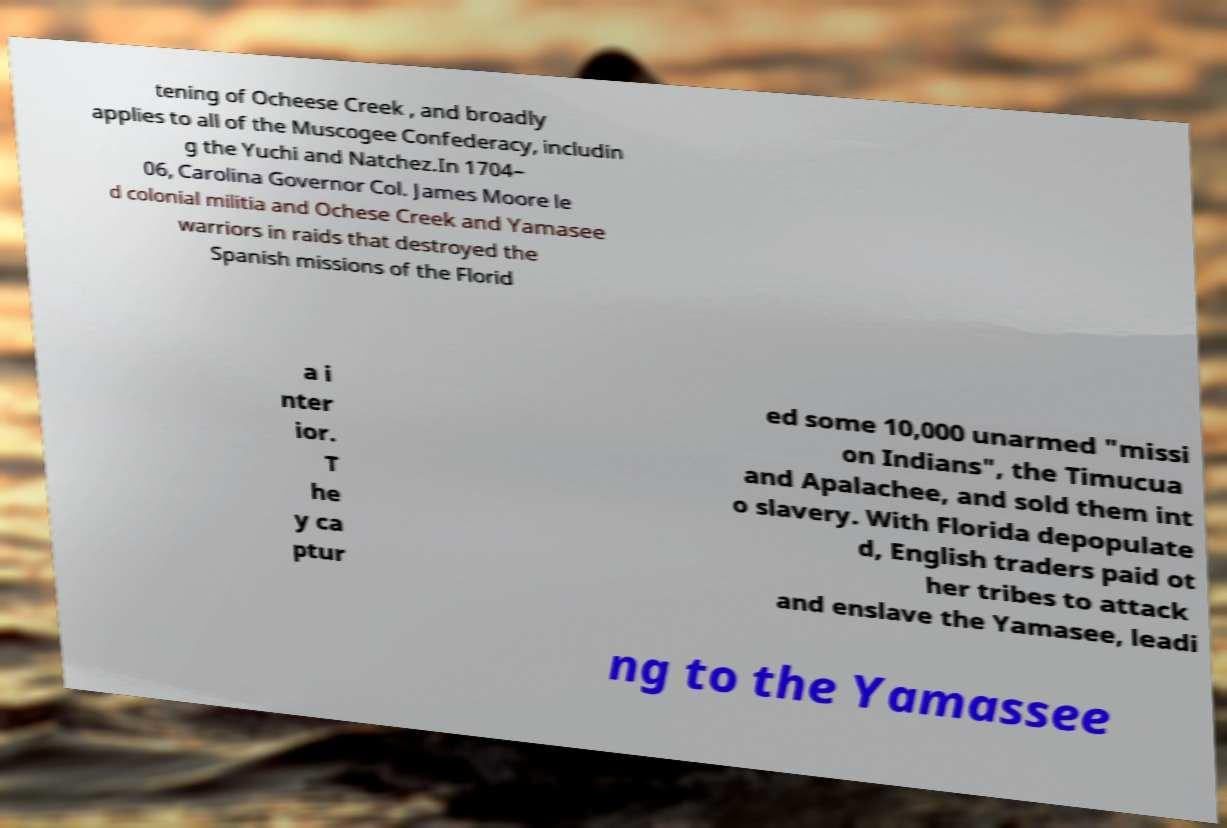What messages or text are displayed in this image? I need them in a readable, typed format. tening of Ocheese Creek , and broadly applies to all of the Muscogee Confederacy, includin g the Yuchi and Natchez.In 1704– 06, Carolina Governor Col. James Moore le d colonial militia and Ochese Creek and Yamasee warriors in raids that destroyed the Spanish missions of the Florid a i nter ior. T he y ca ptur ed some 10,000 unarmed "missi on Indians", the Timucua and Apalachee, and sold them int o slavery. With Florida depopulate d, English traders paid ot her tribes to attack and enslave the Yamasee, leadi ng to the Yamassee 